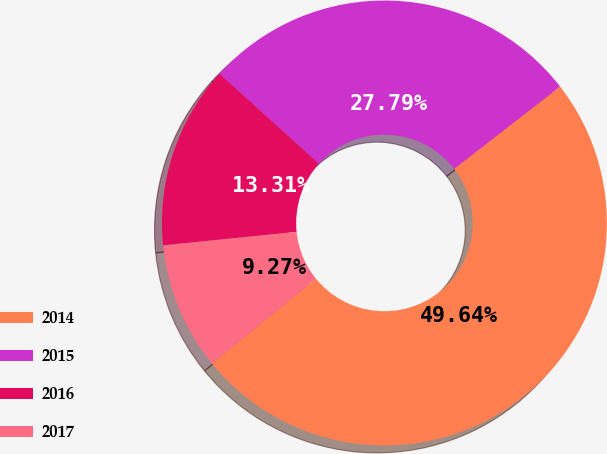<chart> <loc_0><loc_0><loc_500><loc_500><pie_chart><fcel>2014<fcel>2015<fcel>2016<fcel>2017<nl><fcel>49.64%<fcel>27.79%<fcel>13.31%<fcel>9.27%<nl></chart> 